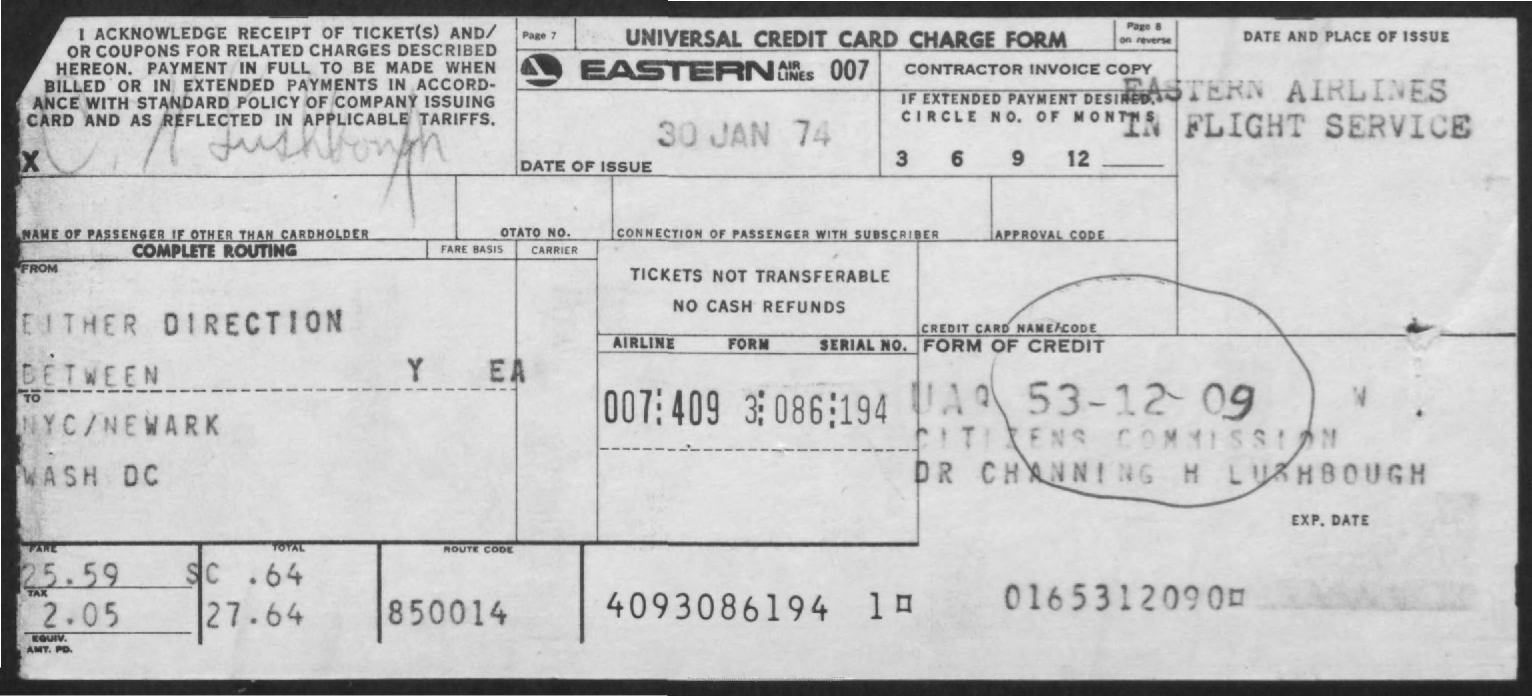What is the Date of Issue?
Your answer should be very brief. 30 Jan 74. What is the Route code?
Offer a terse response. 850014. What is the Fare?
Provide a succinct answer. 25.59. What is the Tax?
Ensure brevity in your answer.  2.05. 